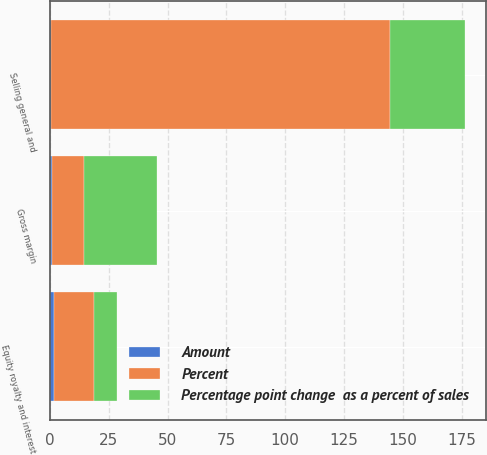<chart> <loc_0><loc_0><loc_500><loc_500><stacked_bar_chart><ecel><fcel>Gross margin<fcel>Selling general and<fcel>Equity royalty and interest<nl><fcel>Percent<fcel>13.5<fcel>144<fcel>17<nl><fcel>Percentage point change  as a percent of sales<fcel>31<fcel>32<fcel>10<nl><fcel>Amount<fcel>0.9<fcel>0.6<fcel>1.5<nl></chart> 